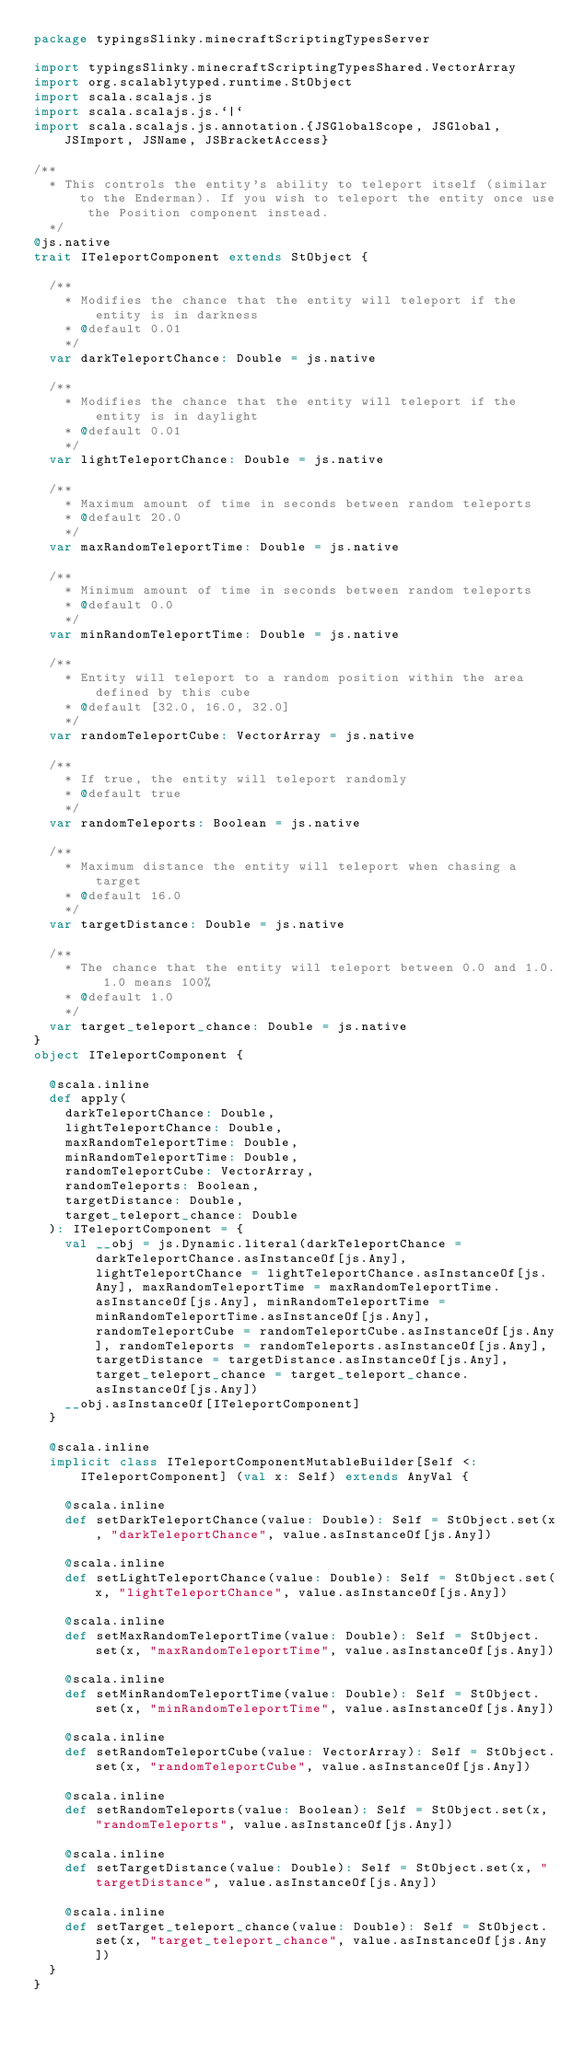<code> <loc_0><loc_0><loc_500><loc_500><_Scala_>package typingsSlinky.minecraftScriptingTypesServer

import typingsSlinky.minecraftScriptingTypesShared.VectorArray
import org.scalablytyped.runtime.StObject
import scala.scalajs.js
import scala.scalajs.js.`|`
import scala.scalajs.js.annotation.{JSGlobalScope, JSGlobal, JSImport, JSName, JSBracketAccess}

/**
  * This controls the entity's ability to teleport itself (similar to the Enderman). If you wish to teleport the entity once use the Position component instead.
  */
@js.native
trait ITeleportComponent extends StObject {
  
  /**
    * Modifies the chance that the entity will teleport if the entity is in darkness
    * @default 0.01
    */
  var darkTeleportChance: Double = js.native
  
  /**
    * Modifies the chance that the entity will teleport if the entity is in daylight
    * @default 0.01
    */
  var lightTeleportChance: Double = js.native
  
  /**
    * Maximum amount of time in seconds between random teleports
    * @default 20.0
    */
  var maxRandomTeleportTime: Double = js.native
  
  /**
    * Minimum amount of time in seconds between random teleports
    * @default 0.0
    */
  var minRandomTeleportTime: Double = js.native
  
  /**
    * Entity will teleport to a random position within the area defined by this cube
    * @default [32.0, 16.0, 32.0]
    */
  var randomTeleportCube: VectorArray = js.native
  
  /**
    * If true, the entity will teleport randomly
    * @default true
    */
  var randomTeleports: Boolean = js.native
  
  /**
    * Maximum distance the entity will teleport when chasing a target
    * @default 16.0
    */
  var targetDistance: Double = js.native
  
  /**
    * The chance that the entity will teleport between 0.0 and 1.0. 1.0 means 100%
    * @default 1.0
    */
  var target_teleport_chance: Double = js.native
}
object ITeleportComponent {
  
  @scala.inline
  def apply(
    darkTeleportChance: Double,
    lightTeleportChance: Double,
    maxRandomTeleportTime: Double,
    minRandomTeleportTime: Double,
    randomTeleportCube: VectorArray,
    randomTeleports: Boolean,
    targetDistance: Double,
    target_teleport_chance: Double
  ): ITeleportComponent = {
    val __obj = js.Dynamic.literal(darkTeleportChance = darkTeleportChance.asInstanceOf[js.Any], lightTeleportChance = lightTeleportChance.asInstanceOf[js.Any], maxRandomTeleportTime = maxRandomTeleportTime.asInstanceOf[js.Any], minRandomTeleportTime = minRandomTeleportTime.asInstanceOf[js.Any], randomTeleportCube = randomTeleportCube.asInstanceOf[js.Any], randomTeleports = randomTeleports.asInstanceOf[js.Any], targetDistance = targetDistance.asInstanceOf[js.Any], target_teleport_chance = target_teleport_chance.asInstanceOf[js.Any])
    __obj.asInstanceOf[ITeleportComponent]
  }
  
  @scala.inline
  implicit class ITeleportComponentMutableBuilder[Self <: ITeleportComponent] (val x: Self) extends AnyVal {
    
    @scala.inline
    def setDarkTeleportChance(value: Double): Self = StObject.set(x, "darkTeleportChance", value.asInstanceOf[js.Any])
    
    @scala.inline
    def setLightTeleportChance(value: Double): Self = StObject.set(x, "lightTeleportChance", value.asInstanceOf[js.Any])
    
    @scala.inline
    def setMaxRandomTeleportTime(value: Double): Self = StObject.set(x, "maxRandomTeleportTime", value.asInstanceOf[js.Any])
    
    @scala.inline
    def setMinRandomTeleportTime(value: Double): Self = StObject.set(x, "minRandomTeleportTime", value.asInstanceOf[js.Any])
    
    @scala.inline
    def setRandomTeleportCube(value: VectorArray): Self = StObject.set(x, "randomTeleportCube", value.asInstanceOf[js.Any])
    
    @scala.inline
    def setRandomTeleports(value: Boolean): Self = StObject.set(x, "randomTeleports", value.asInstanceOf[js.Any])
    
    @scala.inline
    def setTargetDistance(value: Double): Self = StObject.set(x, "targetDistance", value.asInstanceOf[js.Any])
    
    @scala.inline
    def setTarget_teleport_chance(value: Double): Self = StObject.set(x, "target_teleport_chance", value.asInstanceOf[js.Any])
  }
}
</code> 